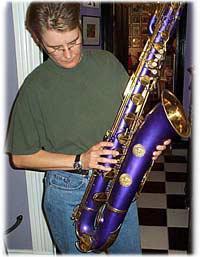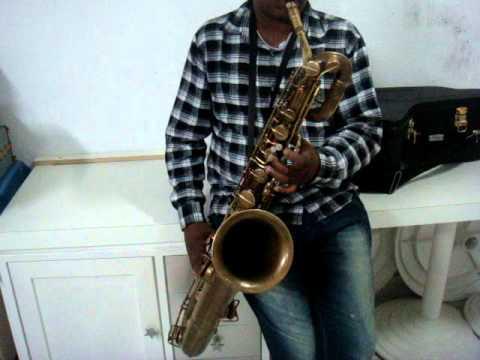The first image is the image on the left, the second image is the image on the right. Assess this claim about the two images: "A person wearing glasses holds a saxophone in the left image.". Correct or not? Answer yes or no. Yes. The first image is the image on the left, the second image is the image on the right. Analyze the images presented: Is the assertion "An image shows a person in a green shirt and jeans holding an instrument." valid? Answer yes or no. Yes. 